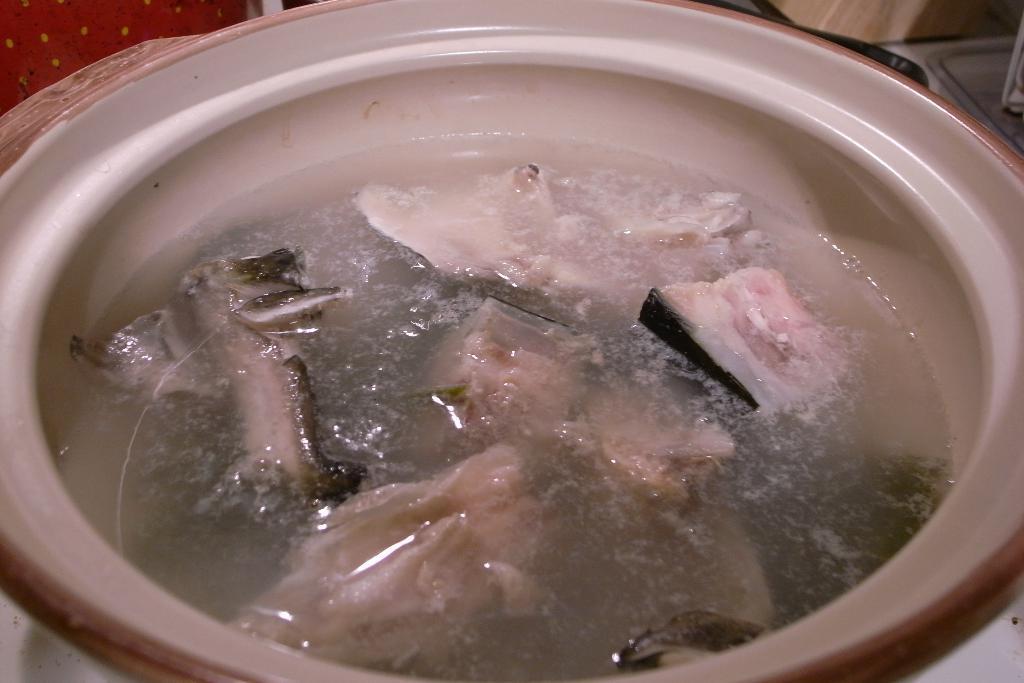In one or two sentences, can you explain what this image depicts? In this image there is a soup in the bowl. 